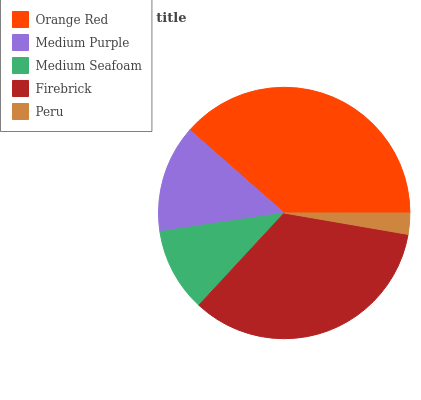Is Peru the minimum?
Answer yes or no. Yes. Is Orange Red the maximum?
Answer yes or no. Yes. Is Medium Purple the minimum?
Answer yes or no. No. Is Medium Purple the maximum?
Answer yes or no. No. Is Orange Red greater than Medium Purple?
Answer yes or no. Yes. Is Medium Purple less than Orange Red?
Answer yes or no. Yes. Is Medium Purple greater than Orange Red?
Answer yes or no. No. Is Orange Red less than Medium Purple?
Answer yes or no. No. Is Medium Purple the high median?
Answer yes or no. Yes. Is Medium Purple the low median?
Answer yes or no. Yes. Is Medium Seafoam the high median?
Answer yes or no. No. Is Medium Seafoam the low median?
Answer yes or no. No. 